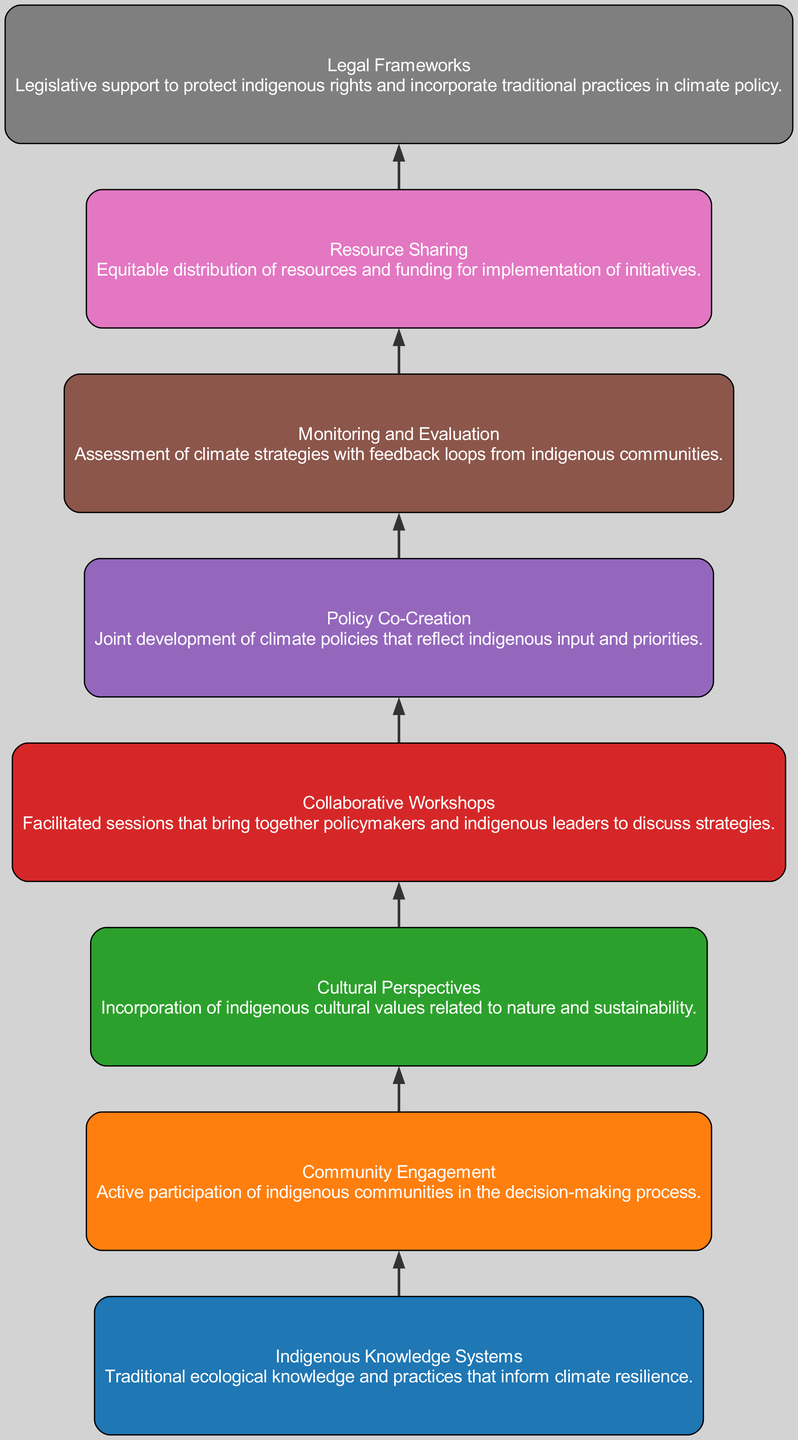What is the first element in the diagram? The diagram starts with "Indigenous Knowledge Systems," as it is the top-most node in the flow chart. This can be identified by looking at the order of the nodes from the bottom to the top.
Answer: Indigenous Knowledge Systems How many nodes are present in the diagram? There are eight distinct elements listed in the diagram, which can be counted by examining the nodes created.
Answer: 8 What follows "Community Engagement" in the flow? The next element after "Community Engagement" is "Cultural Perspectives". This can be determined by looking at the direct connection lines leading from one node to the next in the diagram.
Answer: Cultural Perspectives What is the relationship between "Policy Co-Creation" and "Monitoring and Evaluation"? "Policy Co-Creation" is directly linked to "Monitoring and Evaluation" as it appears sequentially in the flow, indicating that policy co-creation leads to the need for monitoring and evaluation.
Answer: Sequential relationship Which element provides legislative support for indigenous rights? The element "Legal Frameworks" is specifically highlighted as providing the legislative support needed to protect indigenous rights, making it the correct answer when examining the described roles of each node.
Answer: Legal Frameworks What is the last element in the bottom-up flow? The last element at the bottom of the flow chart is "Monitoring and Evaluation," identified by its position in the sequence and the lack of subsequent nodes below it.
Answer: Monitoring and Evaluation Which two elements emphasize the active participation of indigenous communities? "Community Engagement" and "Collaborative Workshops" emphasize the active participation of indigenous communities; both are related to involving indigenous perspectives in policy development, identifiable from their descriptions.
Answer: Community Engagement, Collaborative Workshops How does "Resource Sharing" influence the other elements? "Resource Sharing" supports and enables the effective implementation of initiatives and is crucial for funding, as indicated by its placement in the flow which follows the collaborative processes, thereby influencing all subsequent actions.
Answer: It enables effective implementation What color represents "Cultural Perspectives" in the diagram? "Cultural Perspectives" is colored in a specific shade that corresponds to the color palette used in the diagram. By locating the node, its fill color can be identified as the one assigned to it, which is distinct among the others.
Answer: Orange 